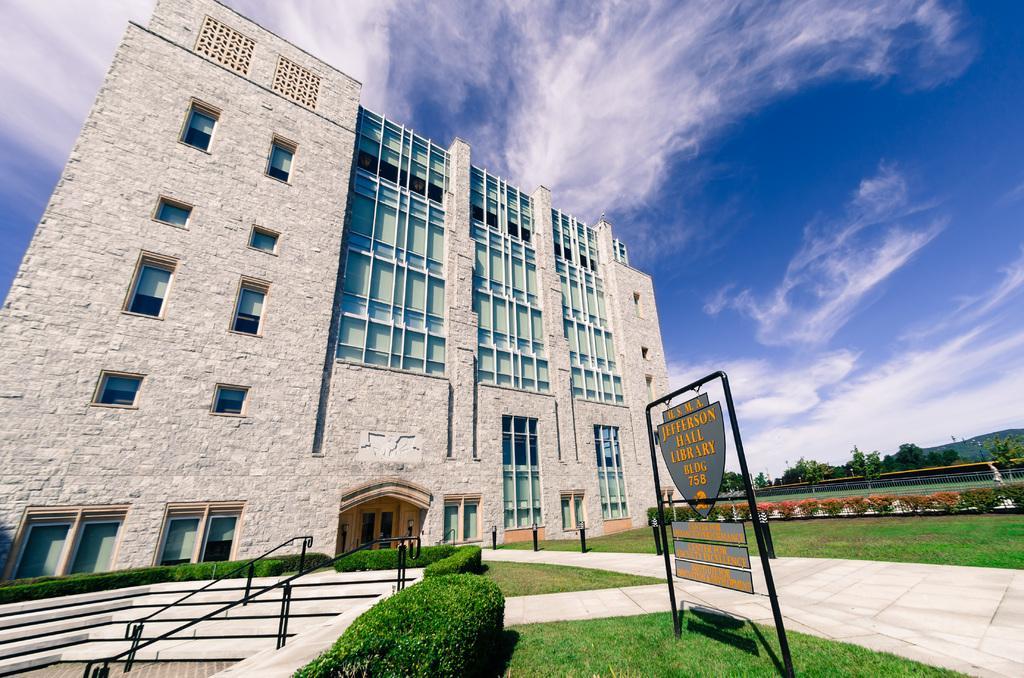Please provide a concise description of this image. In this image I can see a building, the grass, plants, steps and a board which has something written on it. In the background I can see trees and the sky. 